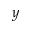Convert formula to latex. <formula><loc_0><loc_0><loc_500><loc_500>y</formula> 